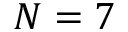<formula> <loc_0><loc_0><loc_500><loc_500>N = 7</formula> 